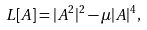Convert formula to latex. <formula><loc_0><loc_0><loc_500><loc_500>L [ A ] = | A ^ { 2 } | ^ { 2 } - \mu | A | ^ { 4 } ,</formula> 